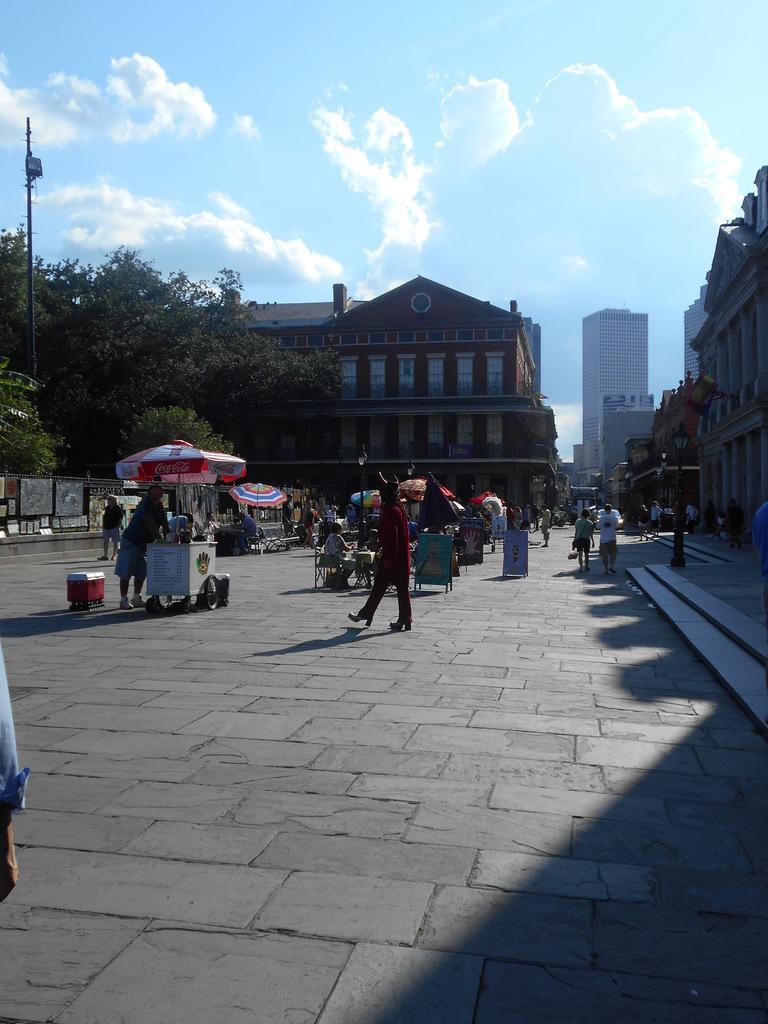Can you describe this image briefly? In this picture I can see the path in front, on which there are number of people I can see and I can see a trolley and I see few umbrellas. In the background I can see the trees and the buildings. On the top of this picture I can see the clear sky and I can see a pole on the left side of this picture. 